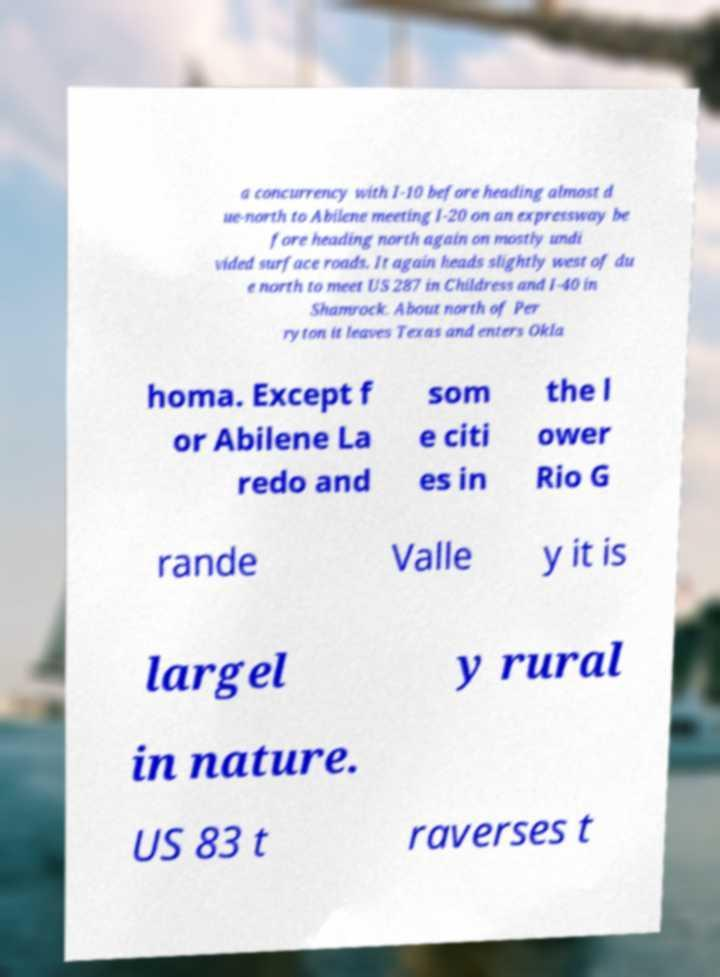There's text embedded in this image that I need extracted. Can you transcribe it verbatim? a concurrency with I-10 before heading almost d ue-north to Abilene meeting I-20 on an expressway be fore heading north again on mostly undi vided surface roads. It again heads slightly west of du e north to meet US 287 in Childress and I-40 in Shamrock. About north of Per ryton it leaves Texas and enters Okla homa. Except f or Abilene La redo and som e citi es in the l ower Rio G rande Valle y it is largel y rural in nature. US 83 t raverses t 